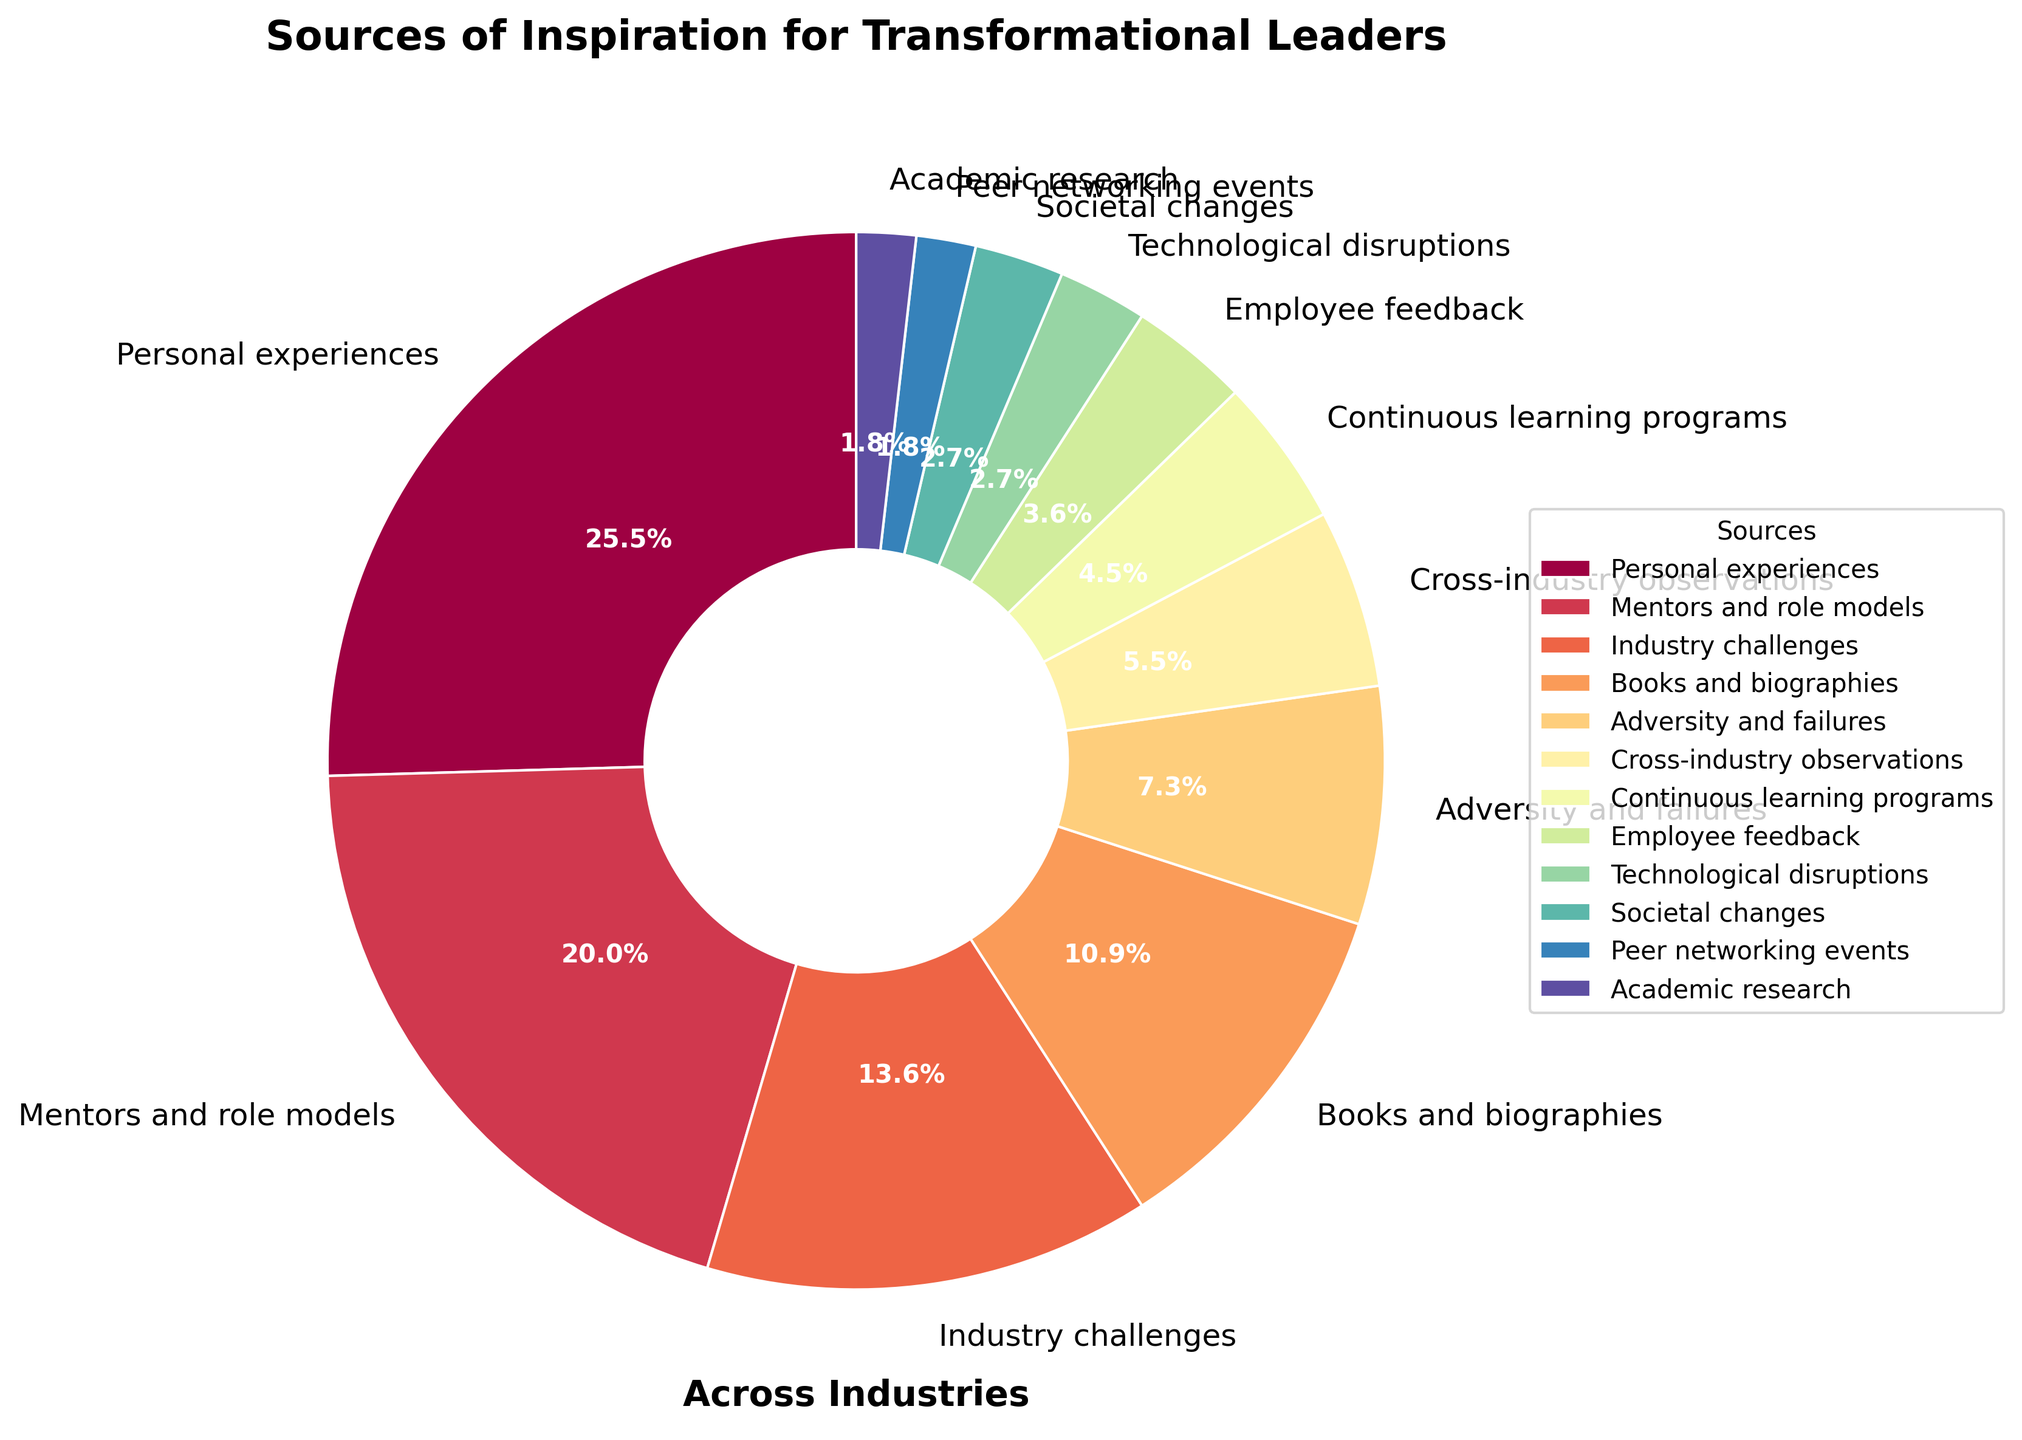What's the sum of the percentages for 'Personal experiences' and 'Mentors and role models'? Add the percentage values for 'Personal experiences' (28%) and 'Mentors and role models' (22%). This gives: 28% + 22% = 50%.
Answer: 50% Which source has the lowest percentage? According to the pie chart, 'Peer networking events' and 'Academic research' both have the lowest percentage, each contributing only 2%.
Answer: Peer networking events and Academic research Are the percentages for 'Books and biographies' greater than 'Adversity and failures'? Compare the percentage values: 'Books and biographies' has 12% while 'Adversity and failures' has 8%, and 12% is indeed greater than 8%.
Answer: Yes Whose percentage is just half of 'Industry challenges'? First check the percentage of 'Industry challenges' which is 15%. Half of 15% is 7.5%. The closest value is 'Adversity and failures' at 8%.
Answer: Adversity and failures What is the difference in percentage between 'Employee feedback' and 'Technological disruptions'? Subtract the percentage values: 'Employee feedback' is 4%, 'Technological disruptions' is 3%. So, the difference is 4% - 3% = 1%.
Answer: 1% Does the pie chart segment for 'Societal changes' look larger, smaller, or equal to 'Technological disruptions'? Both 'Societal changes' and 'Technological disruptions' have the same percentage (3%), so their segments are equal in size.
Answer: Equal What percentage do the sources 'Continuous learning programs' and 'Employee feedback' contribute in total? Add the percentage values: 'Continuous learning programs' (5%) + 'Employee feedback' (4%) = 9%.
Answer: 9% Which has a larger percentage: 'Employee feedback' or 'Cross-industry observations'? 'Employee feedback' has 4% whereas 'Cross-industry observations' has 6%. 6% is larger than 4%.
Answer: Cross-industry observations How many sources have a percentage equal to or less than 5%? The data shows 'Continuous learning programs' (5%), 'Employee feedback' (4%), 'Technological disruptions' (3%), 'Societal changes' (3%), 'Peer networking events' (2%), and 'Academic research' (2%). Counting these sources, there are 6 such sources.
Answer: 6 